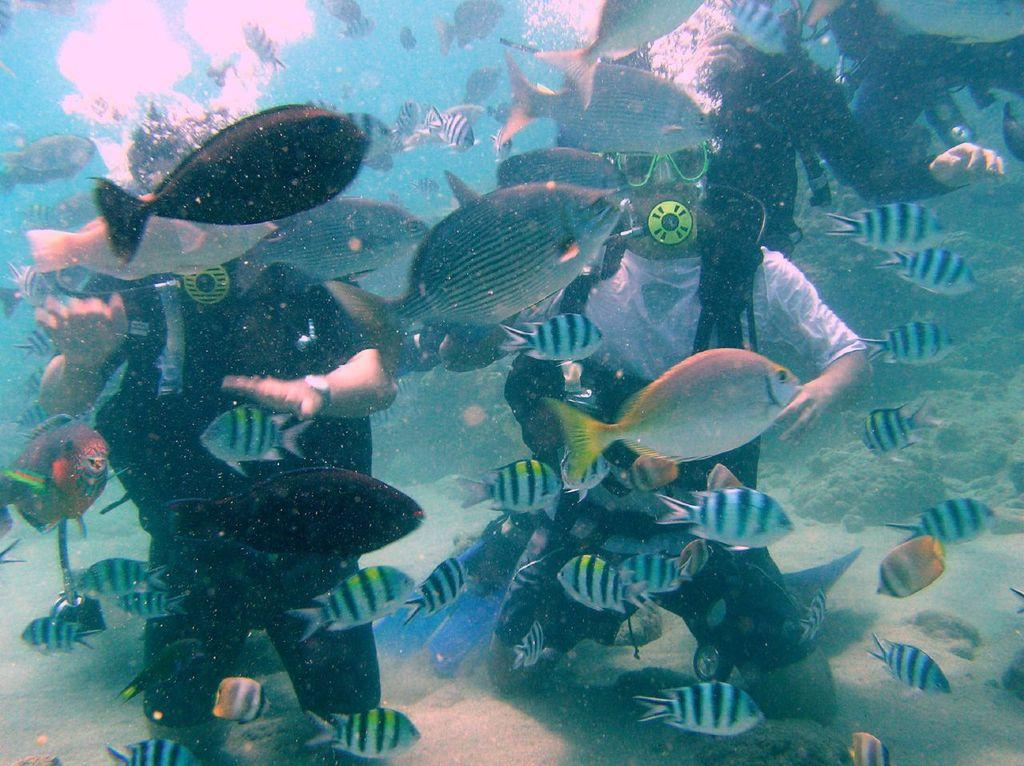What are the two people doing in the image? The two people are visible underwater. What equipment are the people using underwater? The people are wearing regulators. What other living organisms can be seen in the image? There are fishes visible in the image. Can you describe the position of the third person in the image? There is another person visible at the top, underwater. What type of linen is being used to dry the pets in the image? There is no linen or pets present in the image; it features two people and fishes underwater. 